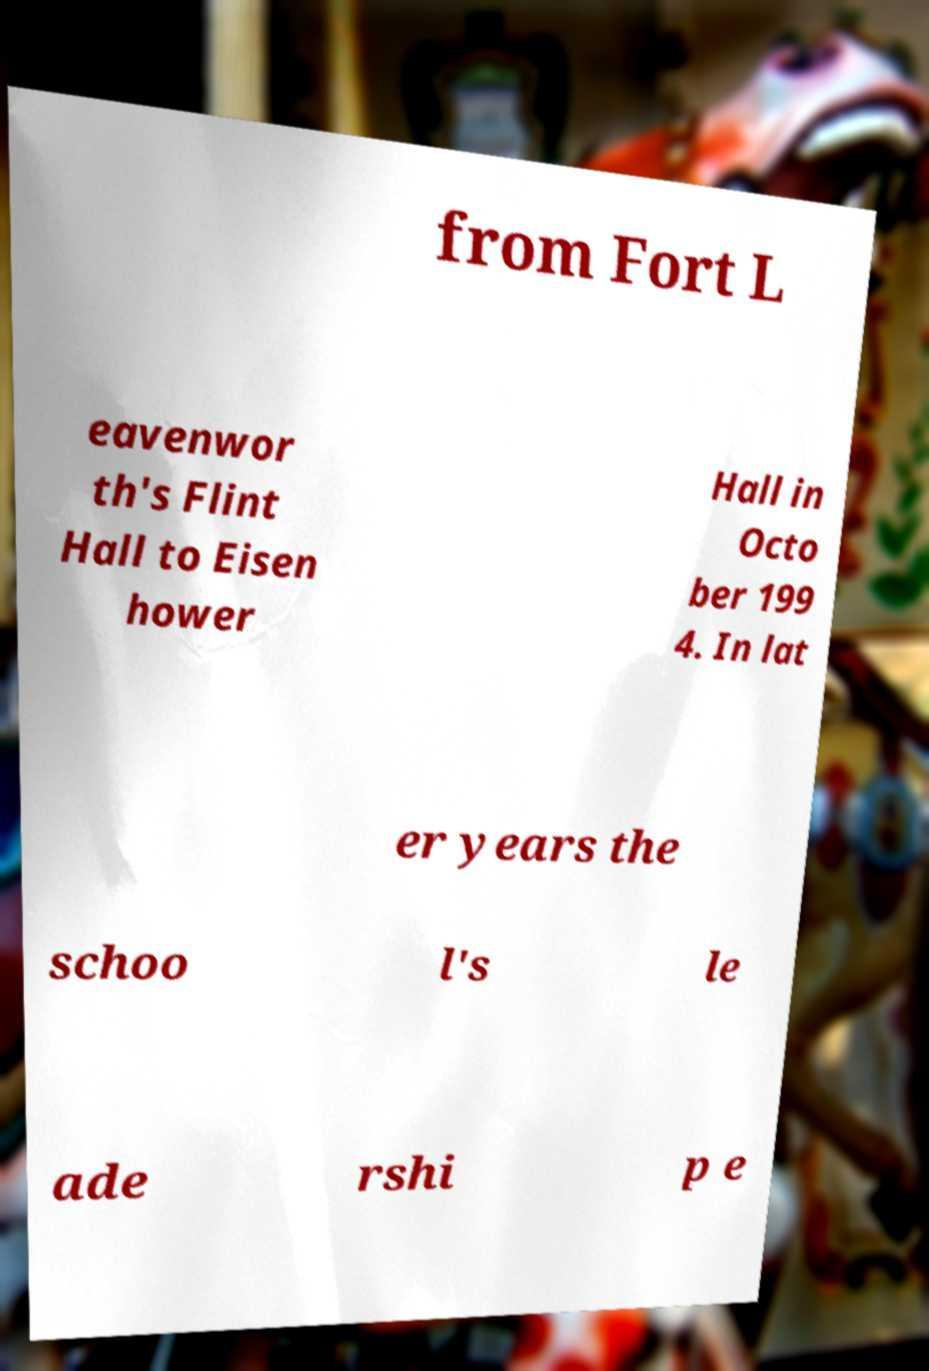Please identify and transcribe the text found in this image. from Fort L eavenwor th's Flint Hall to Eisen hower Hall in Octo ber 199 4. In lat er years the schoo l's le ade rshi p e 